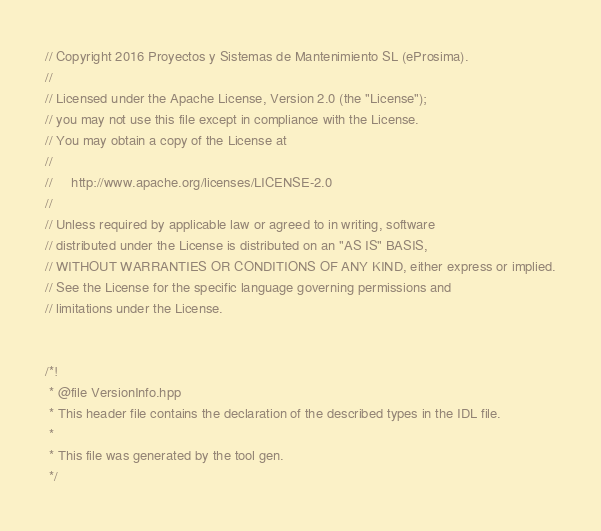<code> <loc_0><loc_0><loc_500><loc_500><_C++_>// Copyright 2016 Proyectos y Sistemas de Mantenimiento SL (eProsima).
//
// Licensed under the Apache License, Version 2.0 (the "License");
// you may not use this file except in compliance with the License.
// You may obtain a copy of the License at
//
//     http://www.apache.org/licenses/LICENSE-2.0
//
// Unless required by applicable law or agreed to in writing, software
// distributed under the License is distributed on an "AS IS" BASIS,
// WITHOUT WARRANTIES OR CONDITIONS OF ANY KIND, either express or implied.
// See the License for the specific language governing permissions and
// limitations under the License.


/*! 
 * @file VersionInfo.hpp
 * This header file contains the declaration of the described types in the IDL file.
 *
 * This file was generated by the tool gen.
 */</code> 